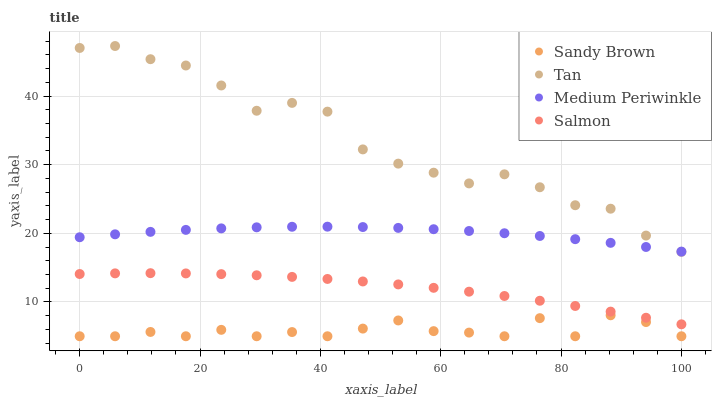Does Sandy Brown have the minimum area under the curve?
Answer yes or no. Yes. Does Tan have the maximum area under the curve?
Answer yes or no. Yes. Does Tan have the minimum area under the curve?
Answer yes or no. No. Does Sandy Brown have the maximum area under the curve?
Answer yes or no. No. Is Salmon the smoothest?
Answer yes or no. Yes. Is Tan the roughest?
Answer yes or no. Yes. Is Sandy Brown the smoothest?
Answer yes or no. No. Is Sandy Brown the roughest?
Answer yes or no. No. Does Sandy Brown have the lowest value?
Answer yes or no. Yes. Does Tan have the lowest value?
Answer yes or no. No. Does Tan have the highest value?
Answer yes or no. Yes. Does Sandy Brown have the highest value?
Answer yes or no. No. Is Salmon less than Tan?
Answer yes or no. Yes. Is Tan greater than Salmon?
Answer yes or no. Yes. Does Tan intersect Medium Periwinkle?
Answer yes or no. Yes. Is Tan less than Medium Periwinkle?
Answer yes or no. No. Is Tan greater than Medium Periwinkle?
Answer yes or no. No. Does Salmon intersect Tan?
Answer yes or no. No. 